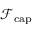<formula> <loc_0><loc_0><loc_500><loc_500>\mathcal { F } _ { c a p }</formula> 